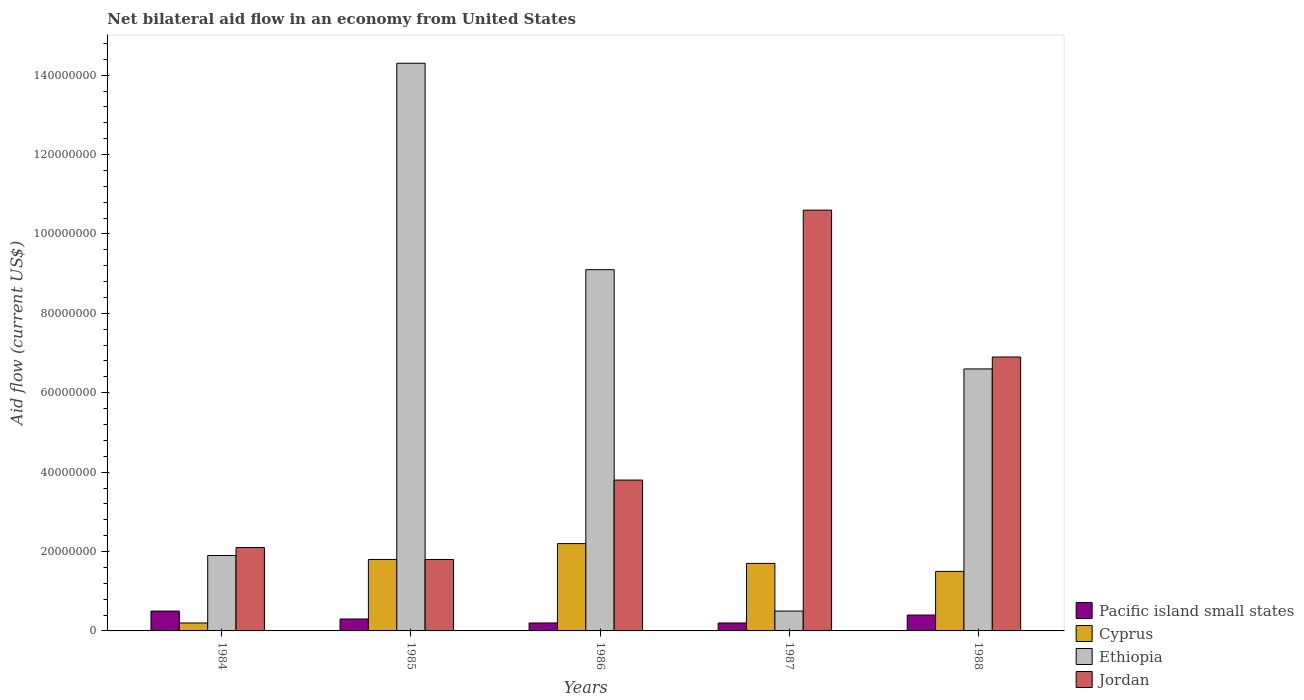How many groups of bars are there?
Provide a succinct answer. 5. How many bars are there on the 4th tick from the right?
Your answer should be very brief. 4. Across all years, what is the maximum net bilateral aid flow in Jordan?
Ensure brevity in your answer.  1.06e+08. Across all years, what is the minimum net bilateral aid flow in Pacific island small states?
Your answer should be compact. 2.00e+06. In which year was the net bilateral aid flow in Cyprus maximum?
Make the answer very short. 1986. In which year was the net bilateral aid flow in Pacific island small states minimum?
Your response must be concise. 1986. What is the total net bilateral aid flow in Pacific island small states in the graph?
Your answer should be compact. 1.60e+07. What is the difference between the net bilateral aid flow in Pacific island small states in 1985 and that in 1986?
Offer a terse response. 1.00e+06. What is the average net bilateral aid flow in Jordan per year?
Make the answer very short. 5.04e+07. In the year 1987, what is the difference between the net bilateral aid flow in Jordan and net bilateral aid flow in Ethiopia?
Your answer should be compact. 1.01e+08. In how many years, is the net bilateral aid flow in Jordan greater than 12000000 US$?
Give a very brief answer. 5. What is the ratio of the net bilateral aid flow in Pacific island small states in 1985 to that in 1986?
Ensure brevity in your answer.  1.5. Is the difference between the net bilateral aid flow in Jordan in 1984 and 1986 greater than the difference between the net bilateral aid flow in Ethiopia in 1984 and 1986?
Give a very brief answer. Yes. What is the difference between the highest and the second highest net bilateral aid flow in Ethiopia?
Keep it short and to the point. 5.20e+07. What is the difference between the highest and the lowest net bilateral aid flow in Ethiopia?
Offer a very short reply. 1.38e+08. In how many years, is the net bilateral aid flow in Jordan greater than the average net bilateral aid flow in Jordan taken over all years?
Provide a short and direct response. 2. What does the 1st bar from the left in 1985 represents?
Offer a terse response. Pacific island small states. What does the 4th bar from the right in 1986 represents?
Your answer should be compact. Pacific island small states. Is it the case that in every year, the sum of the net bilateral aid flow in Pacific island small states and net bilateral aid flow in Cyprus is greater than the net bilateral aid flow in Jordan?
Your answer should be compact. No. How many bars are there?
Give a very brief answer. 20. Are all the bars in the graph horizontal?
Provide a short and direct response. No. How many years are there in the graph?
Provide a short and direct response. 5. What is the difference between two consecutive major ticks on the Y-axis?
Ensure brevity in your answer.  2.00e+07. How many legend labels are there?
Offer a terse response. 4. How are the legend labels stacked?
Give a very brief answer. Vertical. What is the title of the graph?
Your answer should be compact. Net bilateral aid flow in an economy from United States. Does "Paraguay" appear as one of the legend labels in the graph?
Your response must be concise. No. What is the label or title of the X-axis?
Make the answer very short. Years. What is the label or title of the Y-axis?
Give a very brief answer. Aid flow (current US$). What is the Aid flow (current US$) of Ethiopia in 1984?
Your response must be concise. 1.90e+07. What is the Aid flow (current US$) in Jordan in 1984?
Keep it short and to the point. 2.10e+07. What is the Aid flow (current US$) in Pacific island small states in 1985?
Offer a very short reply. 3.00e+06. What is the Aid flow (current US$) of Cyprus in 1985?
Give a very brief answer. 1.80e+07. What is the Aid flow (current US$) of Ethiopia in 1985?
Offer a terse response. 1.43e+08. What is the Aid flow (current US$) of Jordan in 1985?
Offer a terse response. 1.80e+07. What is the Aid flow (current US$) in Cyprus in 1986?
Your response must be concise. 2.20e+07. What is the Aid flow (current US$) in Ethiopia in 1986?
Make the answer very short. 9.10e+07. What is the Aid flow (current US$) of Jordan in 1986?
Offer a very short reply. 3.80e+07. What is the Aid flow (current US$) in Cyprus in 1987?
Your response must be concise. 1.70e+07. What is the Aid flow (current US$) of Ethiopia in 1987?
Your answer should be compact. 5.00e+06. What is the Aid flow (current US$) in Jordan in 1987?
Provide a succinct answer. 1.06e+08. What is the Aid flow (current US$) of Pacific island small states in 1988?
Give a very brief answer. 4.00e+06. What is the Aid flow (current US$) in Cyprus in 1988?
Offer a very short reply. 1.50e+07. What is the Aid flow (current US$) in Ethiopia in 1988?
Give a very brief answer. 6.60e+07. What is the Aid flow (current US$) of Jordan in 1988?
Ensure brevity in your answer.  6.90e+07. Across all years, what is the maximum Aid flow (current US$) in Pacific island small states?
Make the answer very short. 5.00e+06. Across all years, what is the maximum Aid flow (current US$) in Cyprus?
Your answer should be compact. 2.20e+07. Across all years, what is the maximum Aid flow (current US$) in Ethiopia?
Give a very brief answer. 1.43e+08. Across all years, what is the maximum Aid flow (current US$) in Jordan?
Ensure brevity in your answer.  1.06e+08. Across all years, what is the minimum Aid flow (current US$) of Pacific island small states?
Make the answer very short. 2.00e+06. Across all years, what is the minimum Aid flow (current US$) in Cyprus?
Your answer should be compact. 2.00e+06. Across all years, what is the minimum Aid flow (current US$) of Jordan?
Keep it short and to the point. 1.80e+07. What is the total Aid flow (current US$) in Pacific island small states in the graph?
Make the answer very short. 1.60e+07. What is the total Aid flow (current US$) of Cyprus in the graph?
Make the answer very short. 7.40e+07. What is the total Aid flow (current US$) of Ethiopia in the graph?
Provide a short and direct response. 3.24e+08. What is the total Aid flow (current US$) in Jordan in the graph?
Your answer should be compact. 2.52e+08. What is the difference between the Aid flow (current US$) in Pacific island small states in 1984 and that in 1985?
Provide a succinct answer. 2.00e+06. What is the difference between the Aid flow (current US$) of Cyprus in 1984 and that in 1985?
Give a very brief answer. -1.60e+07. What is the difference between the Aid flow (current US$) in Ethiopia in 1984 and that in 1985?
Offer a very short reply. -1.24e+08. What is the difference between the Aid flow (current US$) in Pacific island small states in 1984 and that in 1986?
Your answer should be very brief. 3.00e+06. What is the difference between the Aid flow (current US$) of Cyprus in 1984 and that in 1986?
Provide a succinct answer. -2.00e+07. What is the difference between the Aid flow (current US$) of Ethiopia in 1984 and that in 1986?
Make the answer very short. -7.20e+07. What is the difference between the Aid flow (current US$) in Jordan in 1984 and that in 1986?
Your answer should be very brief. -1.70e+07. What is the difference between the Aid flow (current US$) of Pacific island small states in 1984 and that in 1987?
Keep it short and to the point. 3.00e+06. What is the difference between the Aid flow (current US$) in Cyprus in 1984 and that in 1987?
Make the answer very short. -1.50e+07. What is the difference between the Aid flow (current US$) of Ethiopia in 1984 and that in 1987?
Offer a terse response. 1.40e+07. What is the difference between the Aid flow (current US$) in Jordan in 1984 and that in 1987?
Offer a terse response. -8.50e+07. What is the difference between the Aid flow (current US$) in Pacific island small states in 1984 and that in 1988?
Your answer should be very brief. 1.00e+06. What is the difference between the Aid flow (current US$) in Cyprus in 1984 and that in 1988?
Provide a short and direct response. -1.30e+07. What is the difference between the Aid flow (current US$) in Ethiopia in 1984 and that in 1988?
Offer a terse response. -4.70e+07. What is the difference between the Aid flow (current US$) in Jordan in 1984 and that in 1988?
Give a very brief answer. -4.80e+07. What is the difference between the Aid flow (current US$) of Pacific island small states in 1985 and that in 1986?
Ensure brevity in your answer.  1.00e+06. What is the difference between the Aid flow (current US$) of Cyprus in 1985 and that in 1986?
Give a very brief answer. -4.00e+06. What is the difference between the Aid flow (current US$) of Ethiopia in 1985 and that in 1986?
Ensure brevity in your answer.  5.20e+07. What is the difference between the Aid flow (current US$) of Jordan in 1985 and that in 1986?
Offer a terse response. -2.00e+07. What is the difference between the Aid flow (current US$) in Pacific island small states in 1985 and that in 1987?
Keep it short and to the point. 1.00e+06. What is the difference between the Aid flow (current US$) of Ethiopia in 1985 and that in 1987?
Your answer should be compact. 1.38e+08. What is the difference between the Aid flow (current US$) of Jordan in 1985 and that in 1987?
Give a very brief answer. -8.80e+07. What is the difference between the Aid flow (current US$) of Pacific island small states in 1985 and that in 1988?
Give a very brief answer. -1.00e+06. What is the difference between the Aid flow (current US$) in Ethiopia in 1985 and that in 1988?
Make the answer very short. 7.70e+07. What is the difference between the Aid flow (current US$) of Jordan in 1985 and that in 1988?
Your answer should be very brief. -5.10e+07. What is the difference between the Aid flow (current US$) of Ethiopia in 1986 and that in 1987?
Offer a very short reply. 8.60e+07. What is the difference between the Aid flow (current US$) in Jordan in 1986 and that in 1987?
Your answer should be compact. -6.80e+07. What is the difference between the Aid flow (current US$) of Pacific island small states in 1986 and that in 1988?
Keep it short and to the point. -2.00e+06. What is the difference between the Aid flow (current US$) of Cyprus in 1986 and that in 1988?
Provide a succinct answer. 7.00e+06. What is the difference between the Aid flow (current US$) in Ethiopia in 1986 and that in 1988?
Your answer should be very brief. 2.50e+07. What is the difference between the Aid flow (current US$) in Jordan in 1986 and that in 1988?
Offer a very short reply. -3.10e+07. What is the difference between the Aid flow (current US$) of Ethiopia in 1987 and that in 1988?
Offer a very short reply. -6.10e+07. What is the difference between the Aid flow (current US$) in Jordan in 1987 and that in 1988?
Provide a succinct answer. 3.70e+07. What is the difference between the Aid flow (current US$) of Pacific island small states in 1984 and the Aid flow (current US$) of Cyprus in 1985?
Offer a very short reply. -1.30e+07. What is the difference between the Aid flow (current US$) of Pacific island small states in 1984 and the Aid flow (current US$) of Ethiopia in 1985?
Give a very brief answer. -1.38e+08. What is the difference between the Aid flow (current US$) of Pacific island small states in 1984 and the Aid flow (current US$) of Jordan in 1985?
Provide a succinct answer. -1.30e+07. What is the difference between the Aid flow (current US$) in Cyprus in 1984 and the Aid flow (current US$) in Ethiopia in 1985?
Offer a terse response. -1.41e+08. What is the difference between the Aid flow (current US$) of Cyprus in 1984 and the Aid flow (current US$) of Jordan in 1985?
Your response must be concise. -1.60e+07. What is the difference between the Aid flow (current US$) in Pacific island small states in 1984 and the Aid flow (current US$) in Cyprus in 1986?
Give a very brief answer. -1.70e+07. What is the difference between the Aid flow (current US$) of Pacific island small states in 1984 and the Aid flow (current US$) of Ethiopia in 1986?
Make the answer very short. -8.60e+07. What is the difference between the Aid flow (current US$) in Pacific island small states in 1984 and the Aid flow (current US$) in Jordan in 1986?
Provide a short and direct response. -3.30e+07. What is the difference between the Aid flow (current US$) in Cyprus in 1984 and the Aid flow (current US$) in Ethiopia in 1986?
Provide a short and direct response. -8.90e+07. What is the difference between the Aid flow (current US$) in Cyprus in 1984 and the Aid flow (current US$) in Jordan in 1986?
Provide a succinct answer. -3.60e+07. What is the difference between the Aid flow (current US$) in Ethiopia in 1984 and the Aid flow (current US$) in Jordan in 1986?
Offer a very short reply. -1.90e+07. What is the difference between the Aid flow (current US$) in Pacific island small states in 1984 and the Aid flow (current US$) in Cyprus in 1987?
Make the answer very short. -1.20e+07. What is the difference between the Aid flow (current US$) in Pacific island small states in 1984 and the Aid flow (current US$) in Ethiopia in 1987?
Give a very brief answer. 0. What is the difference between the Aid flow (current US$) in Pacific island small states in 1984 and the Aid flow (current US$) in Jordan in 1987?
Keep it short and to the point. -1.01e+08. What is the difference between the Aid flow (current US$) in Cyprus in 1984 and the Aid flow (current US$) in Jordan in 1987?
Your answer should be compact. -1.04e+08. What is the difference between the Aid flow (current US$) in Ethiopia in 1984 and the Aid flow (current US$) in Jordan in 1987?
Your answer should be compact. -8.70e+07. What is the difference between the Aid flow (current US$) in Pacific island small states in 1984 and the Aid flow (current US$) in Cyprus in 1988?
Ensure brevity in your answer.  -1.00e+07. What is the difference between the Aid flow (current US$) of Pacific island small states in 1984 and the Aid flow (current US$) of Ethiopia in 1988?
Provide a short and direct response. -6.10e+07. What is the difference between the Aid flow (current US$) in Pacific island small states in 1984 and the Aid flow (current US$) in Jordan in 1988?
Provide a short and direct response. -6.40e+07. What is the difference between the Aid flow (current US$) of Cyprus in 1984 and the Aid flow (current US$) of Ethiopia in 1988?
Offer a very short reply. -6.40e+07. What is the difference between the Aid flow (current US$) in Cyprus in 1984 and the Aid flow (current US$) in Jordan in 1988?
Ensure brevity in your answer.  -6.70e+07. What is the difference between the Aid flow (current US$) of Ethiopia in 1984 and the Aid flow (current US$) of Jordan in 1988?
Offer a terse response. -5.00e+07. What is the difference between the Aid flow (current US$) of Pacific island small states in 1985 and the Aid flow (current US$) of Cyprus in 1986?
Make the answer very short. -1.90e+07. What is the difference between the Aid flow (current US$) of Pacific island small states in 1985 and the Aid flow (current US$) of Ethiopia in 1986?
Offer a terse response. -8.80e+07. What is the difference between the Aid flow (current US$) of Pacific island small states in 1985 and the Aid flow (current US$) of Jordan in 1986?
Give a very brief answer. -3.50e+07. What is the difference between the Aid flow (current US$) of Cyprus in 1985 and the Aid flow (current US$) of Ethiopia in 1986?
Make the answer very short. -7.30e+07. What is the difference between the Aid flow (current US$) in Cyprus in 1985 and the Aid flow (current US$) in Jordan in 1986?
Your answer should be very brief. -2.00e+07. What is the difference between the Aid flow (current US$) of Ethiopia in 1985 and the Aid flow (current US$) of Jordan in 1986?
Your answer should be compact. 1.05e+08. What is the difference between the Aid flow (current US$) in Pacific island small states in 1985 and the Aid flow (current US$) in Cyprus in 1987?
Your answer should be very brief. -1.40e+07. What is the difference between the Aid flow (current US$) in Pacific island small states in 1985 and the Aid flow (current US$) in Ethiopia in 1987?
Your answer should be very brief. -2.00e+06. What is the difference between the Aid flow (current US$) in Pacific island small states in 1985 and the Aid flow (current US$) in Jordan in 1987?
Keep it short and to the point. -1.03e+08. What is the difference between the Aid flow (current US$) in Cyprus in 1985 and the Aid flow (current US$) in Ethiopia in 1987?
Provide a succinct answer. 1.30e+07. What is the difference between the Aid flow (current US$) of Cyprus in 1985 and the Aid flow (current US$) of Jordan in 1987?
Provide a short and direct response. -8.80e+07. What is the difference between the Aid flow (current US$) in Ethiopia in 1985 and the Aid flow (current US$) in Jordan in 1987?
Provide a short and direct response. 3.70e+07. What is the difference between the Aid flow (current US$) of Pacific island small states in 1985 and the Aid flow (current US$) of Cyprus in 1988?
Your answer should be compact. -1.20e+07. What is the difference between the Aid flow (current US$) of Pacific island small states in 1985 and the Aid flow (current US$) of Ethiopia in 1988?
Keep it short and to the point. -6.30e+07. What is the difference between the Aid flow (current US$) of Pacific island small states in 1985 and the Aid flow (current US$) of Jordan in 1988?
Your response must be concise. -6.60e+07. What is the difference between the Aid flow (current US$) in Cyprus in 1985 and the Aid flow (current US$) in Ethiopia in 1988?
Your answer should be compact. -4.80e+07. What is the difference between the Aid flow (current US$) in Cyprus in 1985 and the Aid flow (current US$) in Jordan in 1988?
Your answer should be very brief. -5.10e+07. What is the difference between the Aid flow (current US$) of Ethiopia in 1985 and the Aid flow (current US$) of Jordan in 1988?
Give a very brief answer. 7.40e+07. What is the difference between the Aid flow (current US$) in Pacific island small states in 1986 and the Aid flow (current US$) in Cyprus in 1987?
Your response must be concise. -1.50e+07. What is the difference between the Aid flow (current US$) of Pacific island small states in 1986 and the Aid flow (current US$) of Jordan in 1987?
Your answer should be very brief. -1.04e+08. What is the difference between the Aid flow (current US$) in Cyprus in 1986 and the Aid flow (current US$) in Ethiopia in 1987?
Ensure brevity in your answer.  1.70e+07. What is the difference between the Aid flow (current US$) in Cyprus in 1986 and the Aid flow (current US$) in Jordan in 1987?
Your answer should be compact. -8.40e+07. What is the difference between the Aid flow (current US$) of Ethiopia in 1986 and the Aid flow (current US$) of Jordan in 1987?
Offer a very short reply. -1.50e+07. What is the difference between the Aid flow (current US$) of Pacific island small states in 1986 and the Aid flow (current US$) of Cyprus in 1988?
Make the answer very short. -1.30e+07. What is the difference between the Aid flow (current US$) of Pacific island small states in 1986 and the Aid flow (current US$) of Ethiopia in 1988?
Keep it short and to the point. -6.40e+07. What is the difference between the Aid flow (current US$) of Pacific island small states in 1986 and the Aid flow (current US$) of Jordan in 1988?
Your answer should be compact. -6.70e+07. What is the difference between the Aid flow (current US$) of Cyprus in 1986 and the Aid flow (current US$) of Ethiopia in 1988?
Offer a terse response. -4.40e+07. What is the difference between the Aid flow (current US$) in Cyprus in 1986 and the Aid flow (current US$) in Jordan in 1988?
Your answer should be compact. -4.70e+07. What is the difference between the Aid flow (current US$) in Ethiopia in 1986 and the Aid flow (current US$) in Jordan in 1988?
Offer a very short reply. 2.20e+07. What is the difference between the Aid flow (current US$) of Pacific island small states in 1987 and the Aid flow (current US$) of Cyprus in 1988?
Offer a terse response. -1.30e+07. What is the difference between the Aid flow (current US$) in Pacific island small states in 1987 and the Aid flow (current US$) in Ethiopia in 1988?
Offer a very short reply. -6.40e+07. What is the difference between the Aid flow (current US$) in Pacific island small states in 1987 and the Aid flow (current US$) in Jordan in 1988?
Ensure brevity in your answer.  -6.70e+07. What is the difference between the Aid flow (current US$) in Cyprus in 1987 and the Aid flow (current US$) in Ethiopia in 1988?
Provide a succinct answer. -4.90e+07. What is the difference between the Aid flow (current US$) in Cyprus in 1987 and the Aid flow (current US$) in Jordan in 1988?
Your answer should be very brief. -5.20e+07. What is the difference between the Aid flow (current US$) of Ethiopia in 1987 and the Aid flow (current US$) of Jordan in 1988?
Your answer should be compact. -6.40e+07. What is the average Aid flow (current US$) in Pacific island small states per year?
Keep it short and to the point. 3.20e+06. What is the average Aid flow (current US$) of Cyprus per year?
Offer a terse response. 1.48e+07. What is the average Aid flow (current US$) in Ethiopia per year?
Keep it short and to the point. 6.48e+07. What is the average Aid flow (current US$) of Jordan per year?
Your response must be concise. 5.04e+07. In the year 1984, what is the difference between the Aid flow (current US$) in Pacific island small states and Aid flow (current US$) in Ethiopia?
Your answer should be compact. -1.40e+07. In the year 1984, what is the difference between the Aid flow (current US$) of Pacific island small states and Aid flow (current US$) of Jordan?
Give a very brief answer. -1.60e+07. In the year 1984, what is the difference between the Aid flow (current US$) of Cyprus and Aid flow (current US$) of Ethiopia?
Provide a short and direct response. -1.70e+07. In the year 1984, what is the difference between the Aid flow (current US$) of Cyprus and Aid flow (current US$) of Jordan?
Provide a succinct answer. -1.90e+07. In the year 1985, what is the difference between the Aid flow (current US$) in Pacific island small states and Aid flow (current US$) in Cyprus?
Provide a succinct answer. -1.50e+07. In the year 1985, what is the difference between the Aid flow (current US$) in Pacific island small states and Aid flow (current US$) in Ethiopia?
Provide a succinct answer. -1.40e+08. In the year 1985, what is the difference between the Aid flow (current US$) of Pacific island small states and Aid flow (current US$) of Jordan?
Your response must be concise. -1.50e+07. In the year 1985, what is the difference between the Aid flow (current US$) in Cyprus and Aid flow (current US$) in Ethiopia?
Your response must be concise. -1.25e+08. In the year 1985, what is the difference between the Aid flow (current US$) of Cyprus and Aid flow (current US$) of Jordan?
Offer a terse response. 0. In the year 1985, what is the difference between the Aid flow (current US$) in Ethiopia and Aid flow (current US$) in Jordan?
Ensure brevity in your answer.  1.25e+08. In the year 1986, what is the difference between the Aid flow (current US$) in Pacific island small states and Aid flow (current US$) in Cyprus?
Your answer should be very brief. -2.00e+07. In the year 1986, what is the difference between the Aid flow (current US$) of Pacific island small states and Aid flow (current US$) of Ethiopia?
Provide a succinct answer. -8.90e+07. In the year 1986, what is the difference between the Aid flow (current US$) in Pacific island small states and Aid flow (current US$) in Jordan?
Your answer should be very brief. -3.60e+07. In the year 1986, what is the difference between the Aid flow (current US$) in Cyprus and Aid flow (current US$) in Ethiopia?
Make the answer very short. -6.90e+07. In the year 1986, what is the difference between the Aid flow (current US$) in Cyprus and Aid flow (current US$) in Jordan?
Your answer should be compact. -1.60e+07. In the year 1986, what is the difference between the Aid flow (current US$) of Ethiopia and Aid flow (current US$) of Jordan?
Your response must be concise. 5.30e+07. In the year 1987, what is the difference between the Aid flow (current US$) in Pacific island small states and Aid flow (current US$) in Cyprus?
Keep it short and to the point. -1.50e+07. In the year 1987, what is the difference between the Aid flow (current US$) in Pacific island small states and Aid flow (current US$) in Ethiopia?
Your response must be concise. -3.00e+06. In the year 1987, what is the difference between the Aid flow (current US$) of Pacific island small states and Aid flow (current US$) of Jordan?
Offer a terse response. -1.04e+08. In the year 1987, what is the difference between the Aid flow (current US$) of Cyprus and Aid flow (current US$) of Ethiopia?
Your response must be concise. 1.20e+07. In the year 1987, what is the difference between the Aid flow (current US$) in Cyprus and Aid flow (current US$) in Jordan?
Your response must be concise. -8.90e+07. In the year 1987, what is the difference between the Aid flow (current US$) in Ethiopia and Aid flow (current US$) in Jordan?
Offer a terse response. -1.01e+08. In the year 1988, what is the difference between the Aid flow (current US$) in Pacific island small states and Aid flow (current US$) in Cyprus?
Offer a terse response. -1.10e+07. In the year 1988, what is the difference between the Aid flow (current US$) of Pacific island small states and Aid flow (current US$) of Ethiopia?
Provide a succinct answer. -6.20e+07. In the year 1988, what is the difference between the Aid flow (current US$) of Pacific island small states and Aid flow (current US$) of Jordan?
Offer a very short reply. -6.50e+07. In the year 1988, what is the difference between the Aid flow (current US$) in Cyprus and Aid flow (current US$) in Ethiopia?
Your answer should be compact. -5.10e+07. In the year 1988, what is the difference between the Aid flow (current US$) in Cyprus and Aid flow (current US$) in Jordan?
Offer a very short reply. -5.40e+07. What is the ratio of the Aid flow (current US$) in Pacific island small states in 1984 to that in 1985?
Keep it short and to the point. 1.67. What is the ratio of the Aid flow (current US$) in Ethiopia in 1984 to that in 1985?
Ensure brevity in your answer.  0.13. What is the ratio of the Aid flow (current US$) of Pacific island small states in 1984 to that in 1986?
Offer a very short reply. 2.5. What is the ratio of the Aid flow (current US$) in Cyprus in 1984 to that in 1986?
Your response must be concise. 0.09. What is the ratio of the Aid flow (current US$) in Ethiopia in 1984 to that in 1986?
Offer a very short reply. 0.21. What is the ratio of the Aid flow (current US$) of Jordan in 1984 to that in 1986?
Give a very brief answer. 0.55. What is the ratio of the Aid flow (current US$) of Cyprus in 1984 to that in 1987?
Offer a terse response. 0.12. What is the ratio of the Aid flow (current US$) of Ethiopia in 1984 to that in 1987?
Keep it short and to the point. 3.8. What is the ratio of the Aid flow (current US$) of Jordan in 1984 to that in 1987?
Provide a short and direct response. 0.2. What is the ratio of the Aid flow (current US$) in Cyprus in 1984 to that in 1988?
Offer a very short reply. 0.13. What is the ratio of the Aid flow (current US$) of Ethiopia in 1984 to that in 1988?
Give a very brief answer. 0.29. What is the ratio of the Aid flow (current US$) of Jordan in 1984 to that in 1988?
Your response must be concise. 0.3. What is the ratio of the Aid flow (current US$) in Cyprus in 1985 to that in 1986?
Provide a succinct answer. 0.82. What is the ratio of the Aid flow (current US$) in Ethiopia in 1985 to that in 1986?
Your answer should be very brief. 1.57. What is the ratio of the Aid flow (current US$) of Jordan in 1985 to that in 1986?
Your answer should be very brief. 0.47. What is the ratio of the Aid flow (current US$) of Cyprus in 1985 to that in 1987?
Your response must be concise. 1.06. What is the ratio of the Aid flow (current US$) of Ethiopia in 1985 to that in 1987?
Your answer should be compact. 28.6. What is the ratio of the Aid flow (current US$) in Jordan in 1985 to that in 1987?
Make the answer very short. 0.17. What is the ratio of the Aid flow (current US$) of Pacific island small states in 1985 to that in 1988?
Give a very brief answer. 0.75. What is the ratio of the Aid flow (current US$) in Ethiopia in 1985 to that in 1988?
Provide a short and direct response. 2.17. What is the ratio of the Aid flow (current US$) in Jordan in 1985 to that in 1988?
Your answer should be compact. 0.26. What is the ratio of the Aid flow (current US$) in Pacific island small states in 1986 to that in 1987?
Give a very brief answer. 1. What is the ratio of the Aid flow (current US$) in Cyprus in 1986 to that in 1987?
Provide a succinct answer. 1.29. What is the ratio of the Aid flow (current US$) in Ethiopia in 1986 to that in 1987?
Provide a succinct answer. 18.2. What is the ratio of the Aid flow (current US$) of Jordan in 1986 to that in 1987?
Your answer should be compact. 0.36. What is the ratio of the Aid flow (current US$) of Pacific island small states in 1986 to that in 1988?
Ensure brevity in your answer.  0.5. What is the ratio of the Aid flow (current US$) in Cyprus in 1986 to that in 1988?
Provide a short and direct response. 1.47. What is the ratio of the Aid flow (current US$) in Ethiopia in 1986 to that in 1988?
Ensure brevity in your answer.  1.38. What is the ratio of the Aid flow (current US$) in Jordan in 1986 to that in 1988?
Give a very brief answer. 0.55. What is the ratio of the Aid flow (current US$) in Pacific island small states in 1987 to that in 1988?
Ensure brevity in your answer.  0.5. What is the ratio of the Aid flow (current US$) of Cyprus in 1987 to that in 1988?
Keep it short and to the point. 1.13. What is the ratio of the Aid flow (current US$) in Ethiopia in 1987 to that in 1988?
Ensure brevity in your answer.  0.08. What is the ratio of the Aid flow (current US$) in Jordan in 1987 to that in 1988?
Give a very brief answer. 1.54. What is the difference between the highest and the second highest Aid flow (current US$) in Cyprus?
Your response must be concise. 4.00e+06. What is the difference between the highest and the second highest Aid flow (current US$) of Ethiopia?
Your answer should be very brief. 5.20e+07. What is the difference between the highest and the second highest Aid flow (current US$) in Jordan?
Make the answer very short. 3.70e+07. What is the difference between the highest and the lowest Aid flow (current US$) of Cyprus?
Keep it short and to the point. 2.00e+07. What is the difference between the highest and the lowest Aid flow (current US$) of Ethiopia?
Your answer should be compact. 1.38e+08. What is the difference between the highest and the lowest Aid flow (current US$) in Jordan?
Make the answer very short. 8.80e+07. 